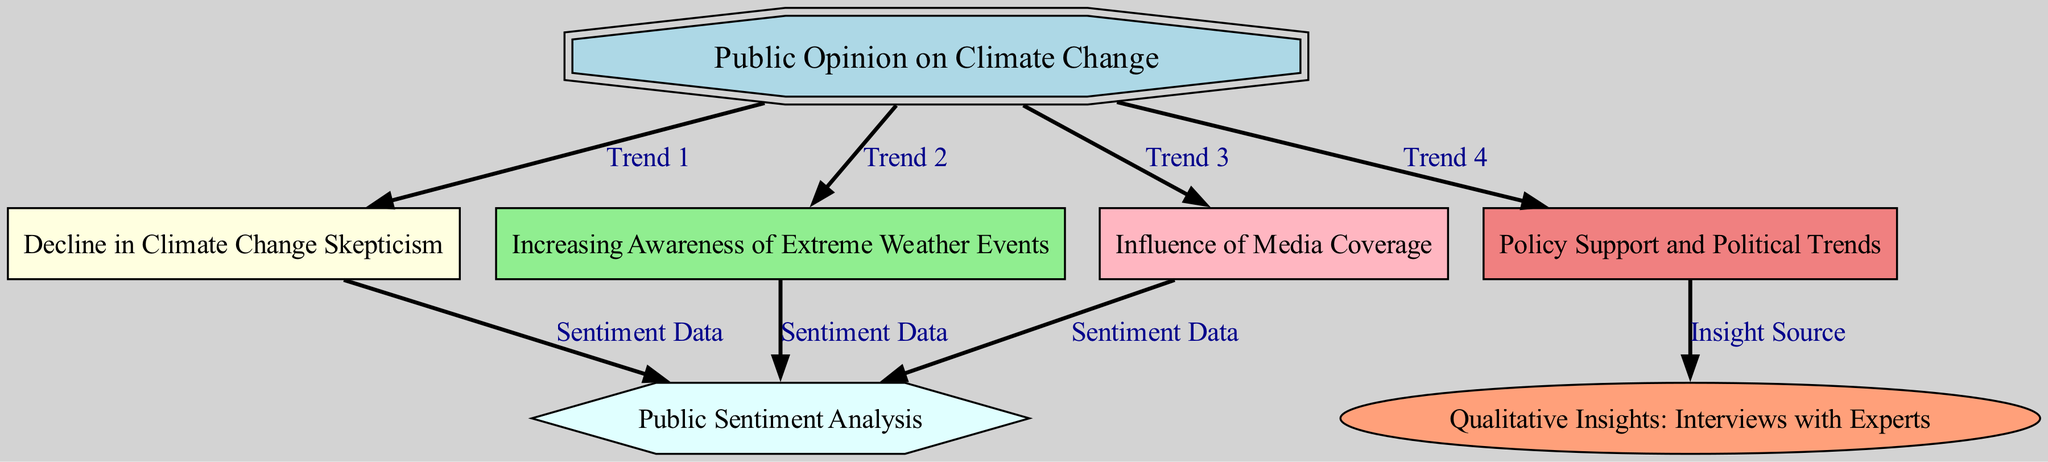What is the central theme of the diagram? The central theme of the diagram, represented by the first node, is "Public Opinion on Climate Change". This node serves as the focal point that connects various trends and insights related to public sentiments and factors influencing opinion.
Answer: Public Opinion on Climate Change How many nodes are present in the diagram? To find the number of nodes, one can count each individual entry within the "nodes" section. In the provided data, there are 7 distinct nodes, each representing a unique aspect of public opinion on climate change.
Answer: 7 What trend is indicated as a direct outcome of the decline in climate change skepticism? The relationship shows that "Decline in Climate Change Skepticism" leads to "Public Sentiment Analysis", meaning that reduced skepticism has a measurable effect on how the public's sentiments about climate change are analyzed and understood.
Answer: Public Sentiment Analysis Which elements influence public opinion according to the diagram? The diagram includes various elements that influence public opinion: "Decline in Climate Change Skepticism", "Increasing Awareness of Extreme Weather Events", "Influence of Media Coverage", and "Policy Support and Political Trends". Each of these nodes represents a distinct factor that contributes to shaping public opinion.
Answer: Four What type of insights are gained from interviews with experts according to the diagram? The "Qualitative Insights: Interviews with Experts" node indicates that insights derived from experts are connected to "Policy Support and Political Trends", suggesting that experts provide valuable information regarding how policies are influenced by shifts in public opinion and awareness of climate change.
Answer: Policy Support and Political Trends How does media coverage affect public opinion on climate change? The diagram shows that "Influence of Media Coverage" directly connects to "Public Sentiment Analysis". This indicates that how the media portrays climate change impacts the overall sentiment and perceptions of the public toward climate-related issues.
Answer: Public Sentiment Analysis What is the connection between public sentiment and the trend of extreme weather events? The "Increasing Awareness of Extreme Weather Events" connects to "Public Sentiment Analysis", demonstrating that as awareness grows due to these events, it significantly influences the public's overall sentiment regarding climate change. This relationship highlights the impact that real-world occurrences have on societal perceptions.
Answer: Public Sentiment Analysis 